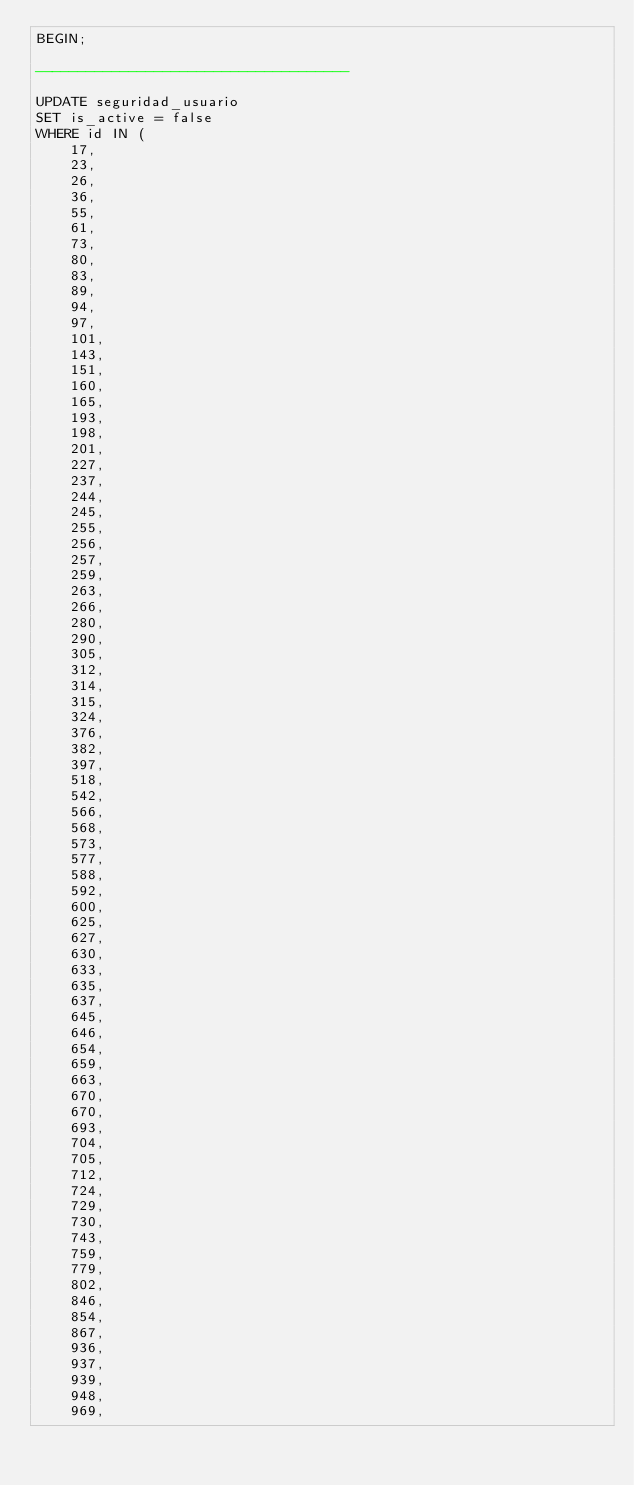<code> <loc_0><loc_0><loc_500><loc_500><_SQL_>BEGIN;

-------------------------------------

UPDATE seguridad_usuario 
SET is_active = false
WHERE id IN (
    17,
    23,
    26,
    36,
    55,
    61,
    73,
    80,
    83,
    89,
    94,
    97,
    101,
    143,
    151,
    160,
    165,
    193,
    198,
    201,
    227,
    237,
    244,
    245,
    255,
    256,
    257,
    259,
    263,
    266,
    280,
    290,
    305,
    312,
    314,
    315,
    324,
    376,
    382,
    397,
    518,
    542,
    566,
    568,
    573,
    577,
    588,
    592,
    600,
    625,
    627,
    630,
    633,
    635,
    637,
    645,
    646,
    654,
    659,
    663,
    670,
    670,
    693,
    704,
    705,
    712,
    724,
    729,
    730,
    743,
    759,
    779,
    802,
    846,
    854,
    867,
    936,
    937,
    939,
    948,
    969,</code> 